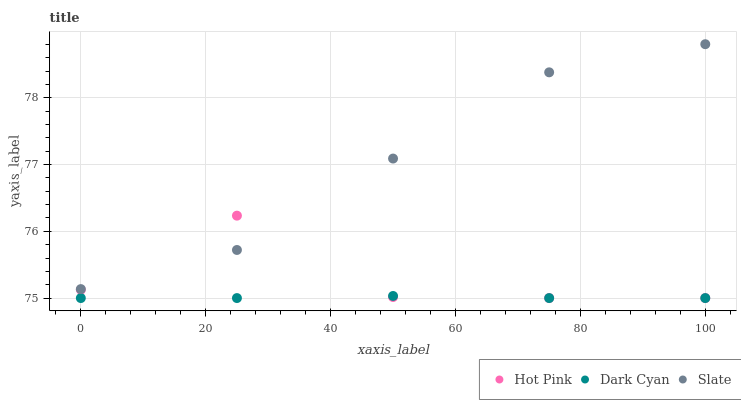Does Dark Cyan have the minimum area under the curve?
Answer yes or no. Yes. Does Slate have the maximum area under the curve?
Answer yes or no. Yes. Does Hot Pink have the minimum area under the curve?
Answer yes or no. No. Does Hot Pink have the maximum area under the curve?
Answer yes or no. No. Is Dark Cyan the smoothest?
Answer yes or no. Yes. Is Hot Pink the roughest?
Answer yes or no. Yes. Is Slate the smoothest?
Answer yes or no. No. Is Slate the roughest?
Answer yes or no. No. Does Dark Cyan have the lowest value?
Answer yes or no. Yes. Does Slate have the lowest value?
Answer yes or no. No. Does Slate have the highest value?
Answer yes or no. Yes. Does Hot Pink have the highest value?
Answer yes or no. No. Is Dark Cyan less than Slate?
Answer yes or no. Yes. Is Slate greater than Dark Cyan?
Answer yes or no. Yes. Does Dark Cyan intersect Hot Pink?
Answer yes or no. Yes. Is Dark Cyan less than Hot Pink?
Answer yes or no. No. Is Dark Cyan greater than Hot Pink?
Answer yes or no. No. Does Dark Cyan intersect Slate?
Answer yes or no. No. 